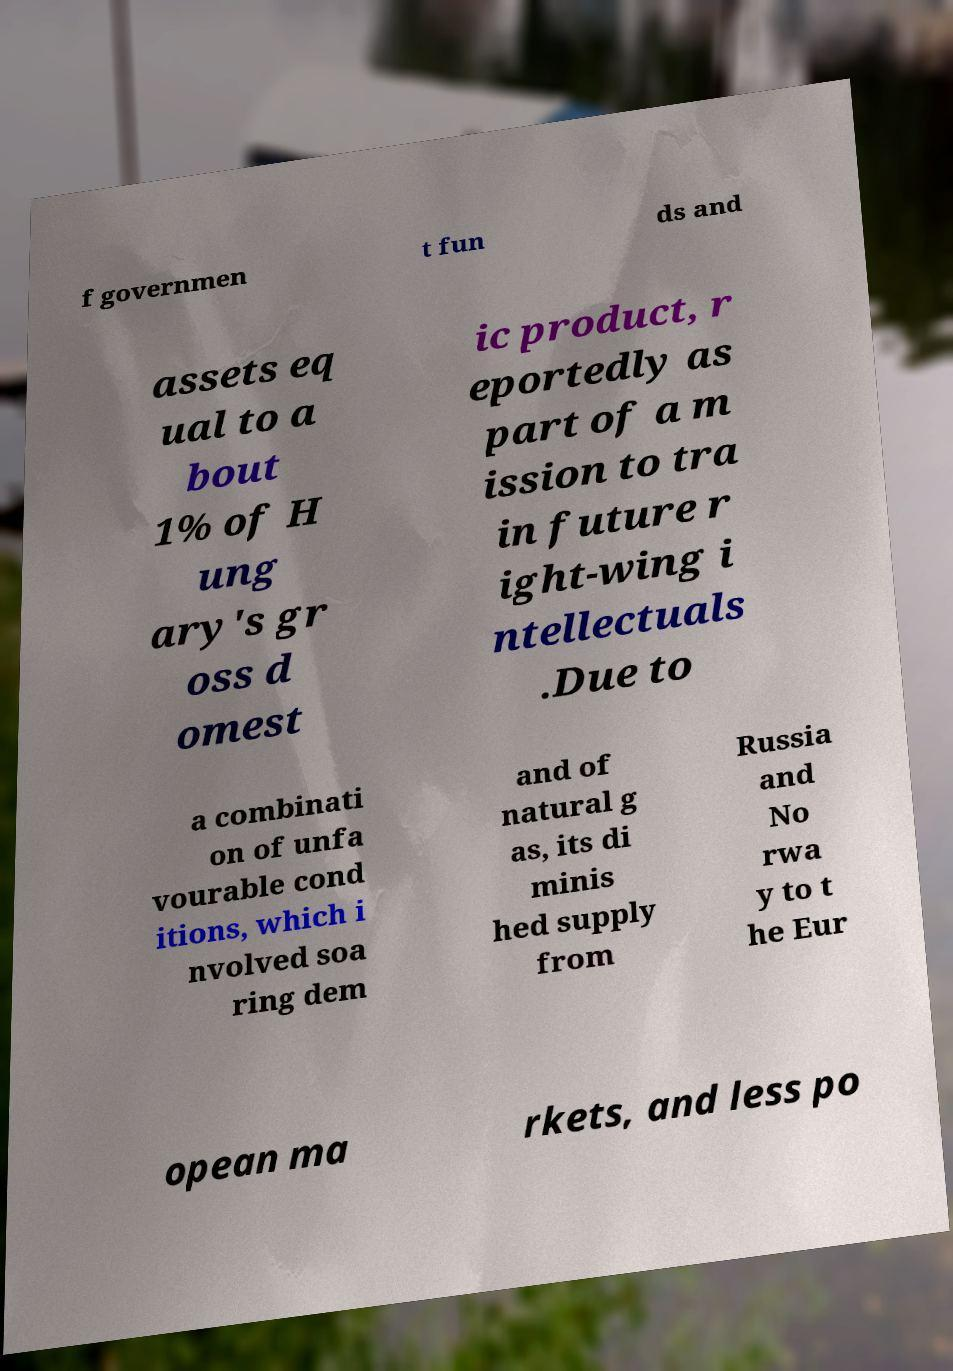I need the written content from this picture converted into text. Can you do that? f governmen t fun ds and assets eq ual to a bout 1% of H ung ary's gr oss d omest ic product, r eportedly as part of a m ission to tra in future r ight-wing i ntellectuals .Due to a combinati on of unfa vourable cond itions, which i nvolved soa ring dem and of natural g as, its di minis hed supply from Russia and No rwa y to t he Eur opean ma rkets, and less po 